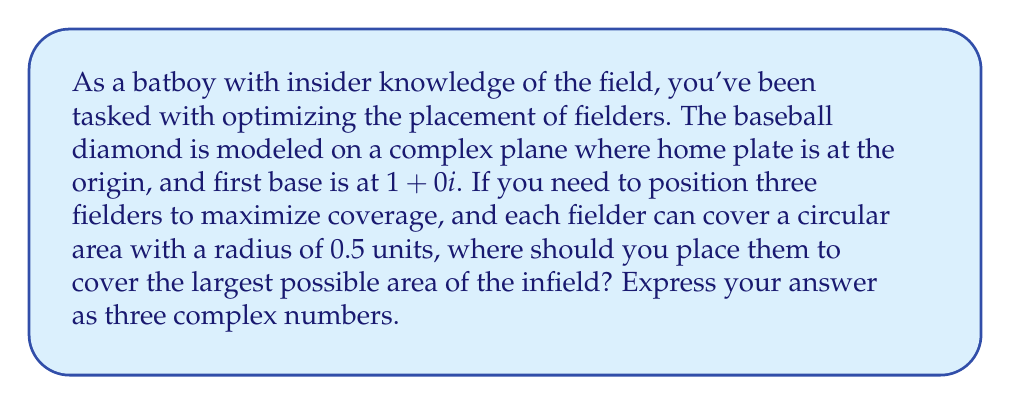Show me your answer to this math problem. Let's approach this step-by-step:

1) First, we need to visualize the baseball diamond on the complex plane. Home plate is at 0+0i, first base at 1+0i, second base at 1+i, and third base at 0+i.

2) To maximize coverage, we want to place the fielders in a way that their coverage areas touch but don't overlap significantly. This arrangement is known as a "close packing" of circles.

3) The optimal arrangement for three circles of equal radius is an equilateral triangle. The centers of these circles will be our fielder positions.

4) To fit this arrangement into our baseball diamond, we can center it at (0.5+0.5i), which is the middle of the infield.

5) The side length of this equilateral triangle will be equal to the diameter of the circles, which is 1 unit (since the radius is 0.5).

6) To calculate the positions, we can use complex number rotations. Starting from the center (0.5+0.5i), we rotate a vector of length $\frac{\sqrt{3}}{3}$ (half the side length of the equilateral triangle) by angles of 0°, 120°, and 240°.

7) The rotation formula in complex form is: $z' = z \cdot (\cos\theta + i\sin\theta)$

8) For 0°: $0.5+0.5i + \frac{\sqrt{3}}{3} \cdot (1+0i) = 0.5+0.5i + \frac{\sqrt{3}}{3} \approx 1.08 + 0.5i$

9) For 120°: $0.5+0.5i + \frac{\sqrt{3}}{3} \cdot (-0.5+\frac{\sqrt{3}}{2}i) \approx 0.21 + 0.79i$

10) For 240°: $0.5+0.5i + \frac{\sqrt{3}}{3} \cdot (-0.5-\frac{\sqrt{3}}{2}i) \approx 0.21 + 0.21i$
Answer: $(1.08+0.5i)$, $(0.21+0.79i)$, $(0.21+0.21i)$ 